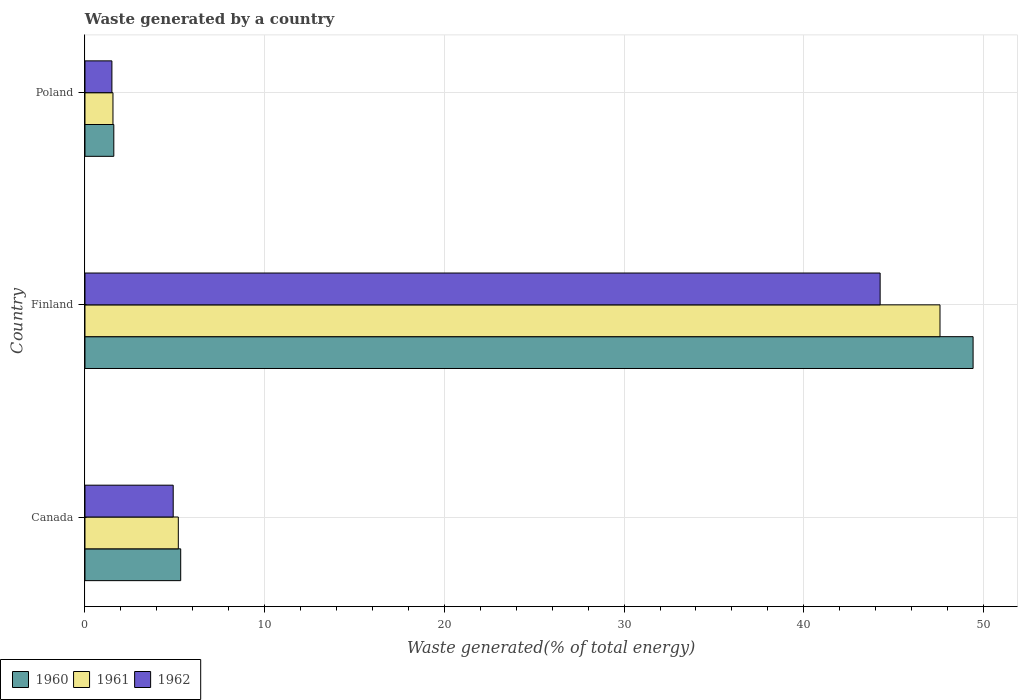Are the number of bars per tick equal to the number of legend labels?
Make the answer very short. Yes. Are the number of bars on each tick of the Y-axis equal?
Your response must be concise. Yes. How many bars are there on the 2nd tick from the bottom?
Your answer should be very brief. 3. What is the total waste generated in 1960 in Canada?
Your response must be concise. 5.33. Across all countries, what is the maximum total waste generated in 1962?
Make the answer very short. 44.25. Across all countries, what is the minimum total waste generated in 1961?
Ensure brevity in your answer.  1.56. In which country was the total waste generated in 1960 maximum?
Your answer should be very brief. Finland. In which country was the total waste generated in 1960 minimum?
Give a very brief answer. Poland. What is the total total waste generated in 1962 in the graph?
Provide a succinct answer. 50.66. What is the difference between the total waste generated in 1960 in Finland and that in Poland?
Your answer should be very brief. 47.82. What is the difference between the total waste generated in 1961 in Poland and the total waste generated in 1960 in Canada?
Your answer should be compact. -3.77. What is the average total waste generated in 1960 per country?
Ensure brevity in your answer.  18.79. What is the difference between the total waste generated in 1961 and total waste generated in 1962 in Canada?
Your response must be concise. 0.28. In how many countries, is the total waste generated in 1960 greater than 16 %?
Make the answer very short. 1. What is the ratio of the total waste generated in 1960 in Canada to that in Finland?
Provide a short and direct response. 0.11. What is the difference between the highest and the second highest total waste generated in 1962?
Provide a succinct answer. 39.34. What is the difference between the highest and the lowest total waste generated in 1962?
Provide a succinct answer. 42.75. Is the sum of the total waste generated in 1960 in Canada and Poland greater than the maximum total waste generated in 1961 across all countries?
Provide a short and direct response. No. How many bars are there?
Offer a terse response. 9. Are all the bars in the graph horizontal?
Offer a terse response. Yes. What is the difference between two consecutive major ticks on the X-axis?
Offer a very short reply. 10. Are the values on the major ticks of X-axis written in scientific E-notation?
Offer a terse response. No. Does the graph contain grids?
Keep it short and to the point. Yes. How are the legend labels stacked?
Offer a very short reply. Horizontal. What is the title of the graph?
Your response must be concise. Waste generated by a country. What is the label or title of the X-axis?
Give a very brief answer. Waste generated(% of total energy). What is the Waste generated(% of total energy) in 1960 in Canada?
Ensure brevity in your answer.  5.33. What is the Waste generated(% of total energy) of 1961 in Canada?
Give a very brief answer. 5.19. What is the Waste generated(% of total energy) in 1962 in Canada?
Provide a succinct answer. 4.91. What is the Waste generated(% of total energy) of 1960 in Finland?
Offer a very short reply. 49.42. What is the Waste generated(% of total energy) in 1961 in Finland?
Your answer should be very brief. 47.58. What is the Waste generated(% of total energy) in 1962 in Finland?
Your response must be concise. 44.25. What is the Waste generated(% of total energy) in 1960 in Poland?
Ensure brevity in your answer.  1.6. What is the Waste generated(% of total energy) of 1961 in Poland?
Provide a short and direct response. 1.56. What is the Waste generated(% of total energy) of 1962 in Poland?
Your answer should be very brief. 1.5. Across all countries, what is the maximum Waste generated(% of total energy) in 1960?
Offer a terse response. 49.42. Across all countries, what is the maximum Waste generated(% of total energy) of 1961?
Offer a terse response. 47.58. Across all countries, what is the maximum Waste generated(% of total energy) in 1962?
Offer a very short reply. 44.25. Across all countries, what is the minimum Waste generated(% of total energy) of 1960?
Provide a succinct answer. 1.6. Across all countries, what is the minimum Waste generated(% of total energy) of 1961?
Give a very brief answer. 1.56. Across all countries, what is the minimum Waste generated(% of total energy) of 1962?
Give a very brief answer. 1.5. What is the total Waste generated(% of total energy) in 1960 in the graph?
Ensure brevity in your answer.  56.36. What is the total Waste generated(% of total energy) in 1961 in the graph?
Offer a very short reply. 54.33. What is the total Waste generated(% of total energy) in 1962 in the graph?
Your answer should be compact. 50.66. What is the difference between the Waste generated(% of total energy) in 1960 in Canada and that in Finland?
Your answer should be very brief. -44.1. What is the difference between the Waste generated(% of total energy) of 1961 in Canada and that in Finland?
Your answer should be compact. -42.39. What is the difference between the Waste generated(% of total energy) of 1962 in Canada and that in Finland?
Your answer should be very brief. -39.34. What is the difference between the Waste generated(% of total energy) in 1960 in Canada and that in Poland?
Your response must be concise. 3.72. What is the difference between the Waste generated(% of total energy) in 1961 in Canada and that in Poland?
Offer a terse response. 3.64. What is the difference between the Waste generated(% of total energy) in 1962 in Canada and that in Poland?
Provide a short and direct response. 3.41. What is the difference between the Waste generated(% of total energy) in 1960 in Finland and that in Poland?
Offer a terse response. 47.82. What is the difference between the Waste generated(% of total energy) in 1961 in Finland and that in Poland?
Ensure brevity in your answer.  46.02. What is the difference between the Waste generated(% of total energy) of 1962 in Finland and that in Poland?
Provide a short and direct response. 42.75. What is the difference between the Waste generated(% of total energy) of 1960 in Canada and the Waste generated(% of total energy) of 1961 in Finland?
Offer a very short reply. -42.25. What is the difference between the Waste generated(% of total energy) in 1960 in Canada and the Waste generated(% of total energy) in 1962 in Finland?
Provide a succinct answer. -38.92. What is the difference between the Waste generated(% of total energy) of 1961 in Canada and the Waste generated(% of total energy) of 1962 in Finland?
Keep it short and to the point. -39.06. What is the difference between the Waste generated(% of total energy) of 1960 in Canada and the Waste generated(% of total energy) of 1961 in Poland?
Offer a very short reply. 3.77. What is the difference between the Waste generated(% of total energy) in 1960 in Canada and the Waste generated(% of total energy) in 1962 in Poland?
Offer a terse response. 3.83. What is the difference between the Waste generated(% of total energy) of 1961 in Canada and the Waste generated(% of total energy) of 1962 in Poland?
Offer a very short reply. 3.7. What is the difference between the Waste generated(% of total energy) in 1960 in Finland and the Waste generated(% of total energy) in 1961 in Poland?
Keep it short and to the point. 47.86. What is the difference between the Waste generated(% of total energy) in 1960 in Finland and the Waste generated(% of total energy) in 1962 in Poland?
Provide a succinct answer. 47.92. What is the difference between the Waste generated(% of total energy) in 1961 in Finland and the Waste generated(% of total energy) in 1962 in Poland?
Provide a succinct answer. 46.08. What is the average Waste generated(% of total energy) in 1960 per country?
Ensure brevity in your answer.  18.79. What is the average Waste generated(% of total energy) in 1961 per country?
Keep it short and to the point. 18.11. What is the average Waste generated(% of total energy) in 1962 per country?
Ensure brevity in your answer.  16.89. What is the difference between the Waste generated(% of total energy) in 1960 and Waste generated(% of total energy) in 1961 in Canada?
Your answer should be compact. 0.13. What is the difference between the Waste generated(% of total energy) in 1960 and Waste generated(% of total energy) in 1962 in Canada?
Offer a very short reply. 0.42. What is the difference between the Waste generated(% of total energy) in 1961 and Waste generated(% of total energy) in 1962 in Canada?
Your response must be concise. 0.28. What is the difference between the Waste generated(% of total energy) in 1960 and Waste generated(% of total energy) in 1961 in Finland?
Offer a very short reply. 1.84. What is the difference between the Waste generated(% of total energy) of 1960 and Waste generated(% of total energy) of 1962 in Finland?
Your answer should be very brief. 5.17. What is the difference between the Waste generated(% of total energy) of 1961 and Waste generated(% of total energy) of 1962 in Finland?
Provide a short and direct response. 3.33. What is the difference between the Waste generated(% of total energy) in 1960 and Waste generated(% of total energy) in 1961 in Poland?
Give a very brief answer. 0.05. What is the difference between the Waste generated(% of total energy) in 1960 and Waste generated(% of total energy) in 1962 in Poland?
Provide a short and direct response. 0.11. What is the difference between the Waste generated(% of total energy) of 1961 and Waste generated(% of total energy) of 1962 in Poland?
Provide a short and direct response. 0.06. What is the ratio of the Waste generated(% of total energy) of 1960 in Canada to that in Finland?
Give a very brief answer. 0.11. What is the ratio of the Waste generated(% of total energy) of 1961 in Canada to that in Finland?
Ensure brevity in your answer.  0.11. What is the ratio of the Waste generated(% of total energy) of 1962 in Canada to that in Finland?
Offer a very short reply. 0.11. What is the ratio of the Waste generated(% of total energy) in 1960 in Canada to that in Poland?
Your answer should be very brief. 3.32. What is the ratio of the Waste generated(% of total energy) in 1961 in Canada to that in Poland?
Offer a terse response. 3.33. What is the ratio of the Waste generated(% of total energy) of 1962 in Canada to that in Poland?
Make the answer very short. 3.28. What is the ratio of the Waste generated(% of total energy) of 1960 in Finland to that in Poland?
Your response must be concise. 30.8. What is the ratio of the Waste generated(% of total energy) in 1961 in Finland to that in Poland?
Offer a terse response. 30.53. What is the ratio of the Waste generated(% of total energy) in 1962 in Finland to that in Poland?
Provide a succinct answer. 29.52. What is the difference between the highest and the second highest Waste generated(% of total energy) in 1960?
Provide a succinct answer. 44.1. What is the difference between the highest and the second highest Waste generated(% of total energy) in 1961?
Provide a succinct answer. 42.39. What is the difference between the highest and the second highest Waste generated(% of total energy) of 1962?
Make the answer very short. 39.34. What is the difference between the highest and the lowest Waste generated(% of total energy) in 1960?
Your answer should be very brief. 47.82. What is the difference between the highest and the lowest Waste generated(% of total energy) in 1961?
Your answer should be compact. 46.02. What is the difference between the highest and the lowest Waste generated(% of total energy) of 1962?
Offer a very short reply. 42.75. 